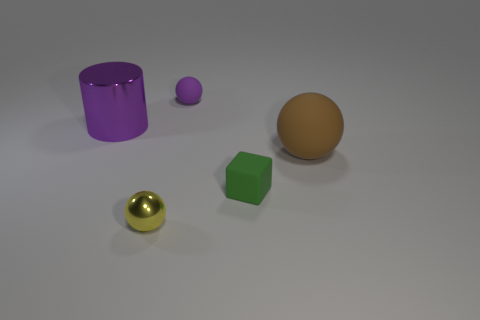There is a brown rubber thing; is its shape the same as the purple thing to the right of the tiny yellow ball?
Give a very brief answer. Yes. What is the size of the thing that is both left of the small purple rubber object and behind the tiny matte block?
Your response must be concise. Large. What is the color of the object that is behind the green cube and right of the tiny rubber ball?
Make the answer very short. Brown. Are there fewer tiny things that are on the right side of the big rubber sphere than big shiny cylinders to the left of the purple sphere?
Your response must be concise. Yes. Are there any other things of the same color as the small matte sphere?
Offer a very short reply. Yes. What is the shape of the tiny green thing?
Your answer should be compact. Cube. What is the color of the big cylinder that is the same material as the yellow object?
Keep it short and to the point. Purple. Are there more big brown objects than small yellow rubber objects?
Provide a short and direct response. Yes. Are any spheres visible?
Ensure brevity in your answer.  Yes. The purple thing that is left of the ball that is behind the big metal thing is what shape?
Your response must be concise. Cylinder. 